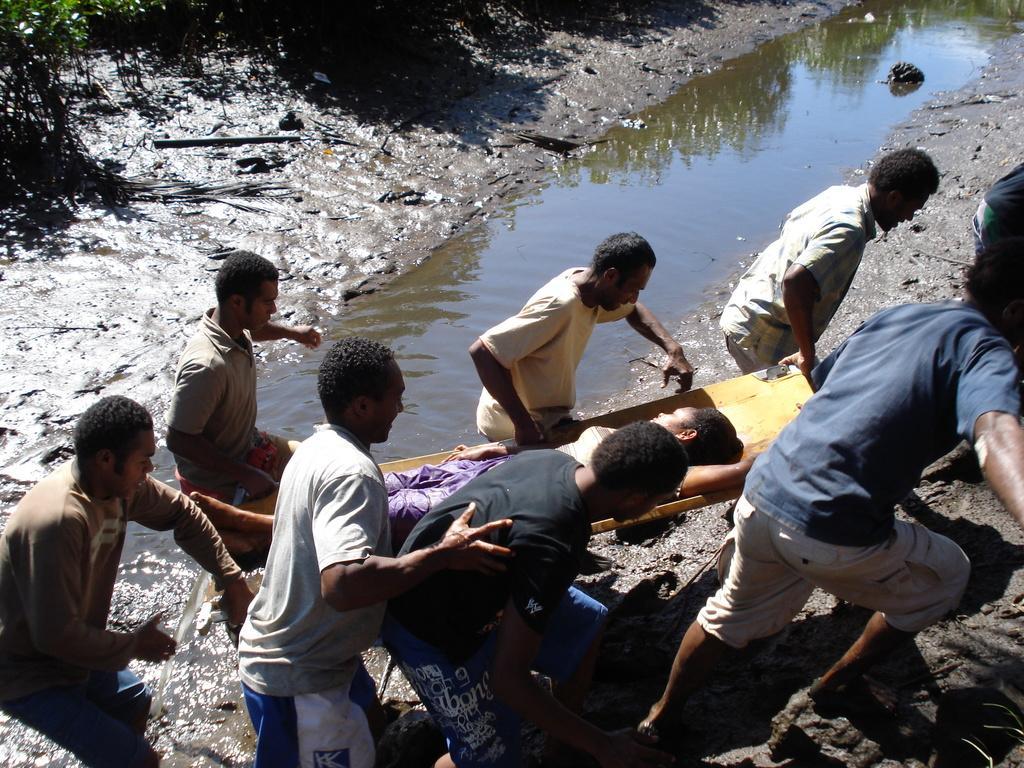Can you describe this image briefly? There are persons in different color dresses, holding a stretcher and walking. There is a woman on the stretcher. Beside them, there is water of a lake. In the background, there are plants. 